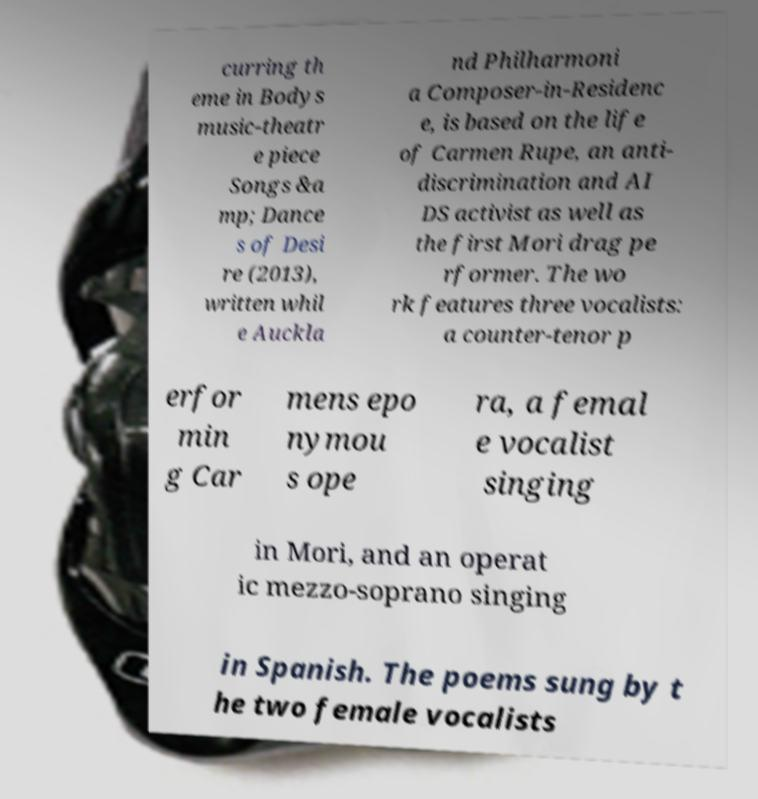Could you assist in decoding the text presented in this image and type it out clearly? curring th eme in Bodys music-theatr e piece Songs &a mp; Dance s of Desi re (2013), written whil e Auckla nd Philharmoni a Composer-in-Residenc e, is based on the life of Carmen Rupe, an anti- discrimination and AI DS activist as well as the first Mori drag pe rformer. The wo rk features three vocalists: a counter-tenor p erfor min g Car mens epo nymou s ope ra, a femal e vocalist singing in Mori, and an operat ic mezzo-soprano singing in Spanish. The poems sung by t he two female vocalists 